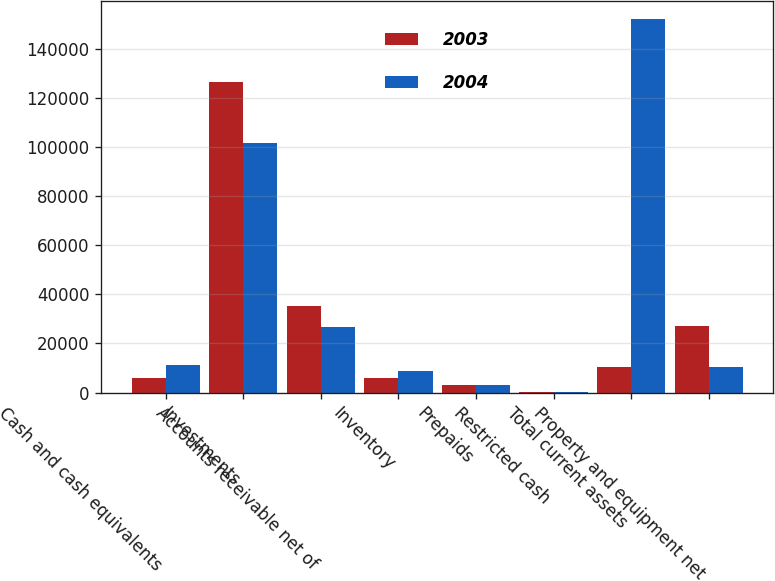Convert chart. <chart><loc_0><loc_0><loc_500><loc_500><stacked_bar_chart><ecel><fcel>Cash and cash equivalents<fcel>Investments<fcel>Accounts receivable net of<fcel>Inventory<fcel>Prepaids<fcel>Restricted cash<fcel>Total current assets<fcel>Property and equipment net<nl><fcel>2003<fcel>5771<fcel>126267<fcel>35443<fcel>5966<fcel>3032<fcel>205<fcel>10288<fcel>27065<nl><fcel>2004<fcel>11335<fcel>101614<fcel>26820<fcel>8788<fcel>3203<fcel>188<fcel>151948<fcel>10288<nl></chart> 